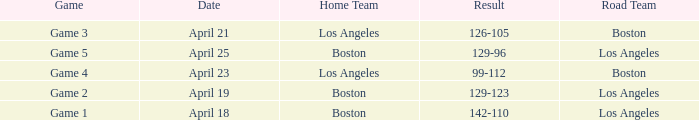WHAT IS THE HOME TEAM, RESULT 99-112? Los Angeles. 